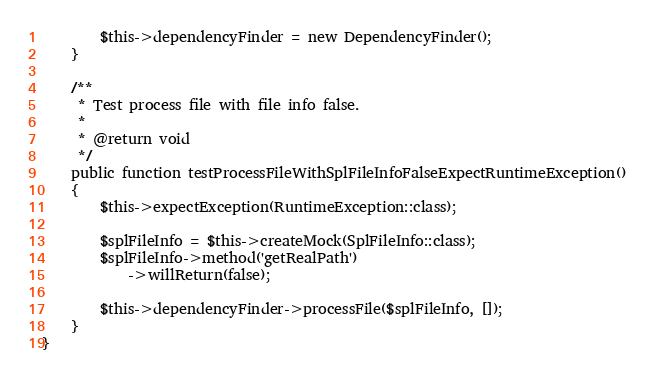Convert code to text. <code><loc_0><loc_0><loc_500><loc_500><_PHP_>        $this->dependencyFinder = new DependencyFinder();
    }

    /**
     * Test process file with file info false.
     *
     * @return void
     */
    public function testProcessFileWithSplFileInfoFalseExpectRuntimeException()
    {
        $this->expectException(RuntimeException::class);

        $splFileInfo = $this->createMock(SplFileInfo::class);
        $splFileInfo->method('getRealPath')
            ->willReturn(false);

        $this->dependencyFinder->processFile($splFileInfo, []);
    }
}
</code> 